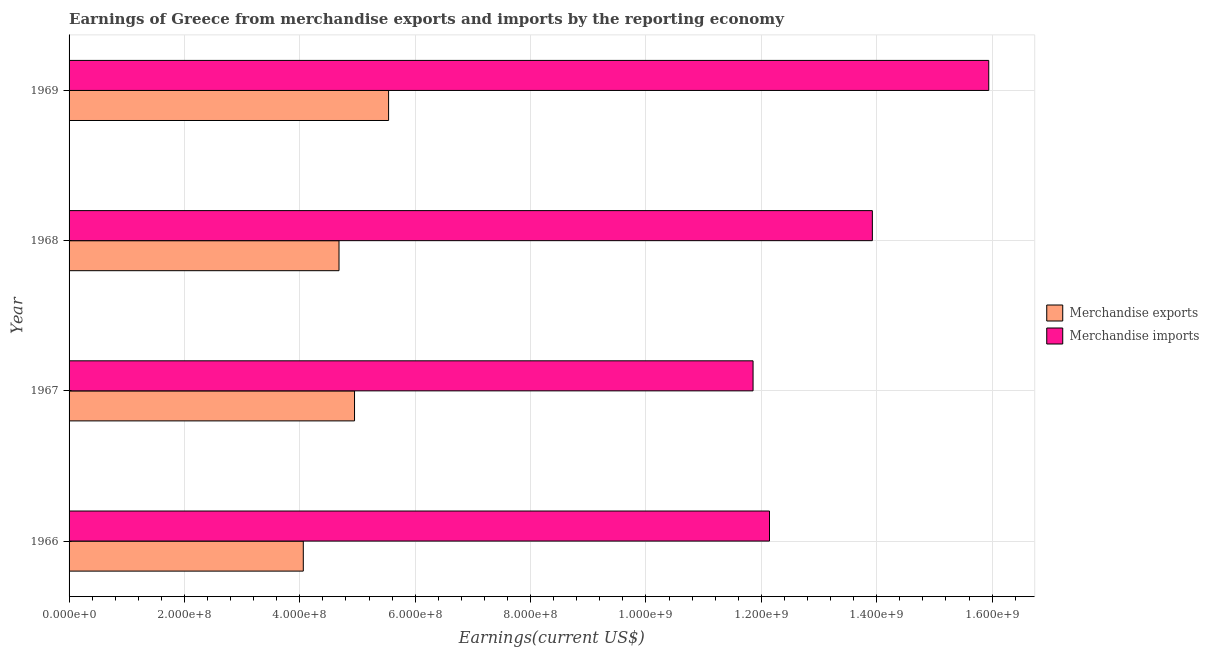Are the number of bars on each tick of the Y-axis equal?
Make the answer very short. Yes. What is the label of the 1st group of bars from the top?
Give a very brief answer. 1969. What is the earnings from merchandise exports in 1968?
Ensure brevity in your answer.  4.68e+08. Across all years, what is the maximum earnings from merchandise exports?
Make the answer very short. 5.54e+08. Across all years, what is the minimum earnings from merchandise exports?
Keep it short and to the point. 4.06e+08. In which year was the earnings from merchandise imports maximum?
Keep it short and to the point. 1969. In which year was the earnings from merchandise exports minimum?
Provide a short and direct response. 1966. What is the total earnings from merchandise exports in the graph?
Ensure brevity in your answer.  1.92e+09. What is the difference between the earnings from merchandise exports in 1967 and that in 1968?
Keep it short and to the point. 2.69e+07. What is the difference between the earnings from merchandise imports in 1966 and the earnings from merchandise exports in 1967?
Provide a short and direct response. 7.19e+08. What is the average earnings from merchandise exports per year?
Provide a succinct answer. 4.81e+08. In the year 1968, what is the difference between the earnings from merchandise exports and earnings from merchandise imports?
Give a very brief answer. -9.24e+08. What is the ratio of the earnings from merchandise exports in 1966 to that in 1967?
Give a very brief answer. 0.82. What is the difference between the highest and the second highest earnings from merchandise imports?
Your answer should be compact. 2.02e+08. What is the difference between the highest and the lowest earnings from merchandise imports?
Provide a short and direct response. 4.09e+08. How many years are there in the graph?
Ensure brevity in your answer.  4. What is the difference between two consecutive major ticks on the X-axis?
Provide a succinct answer. 2.00e+08. Are the values on the major ticks of X-axis written in scientific E-notation?
Provide a short and direct response. Yes. Does the graph contain any zero values?
Offer a terse response. No. How many legend labels are there?
Make the answer very short. 2. What is the title of the graph?
Ensure brevity in your answer.  Earnings of Greece from merchandise exports and imports by the reporting economy. Does "Researchers" appear as one of the legend labels in the graph?
Ensure brevity in your answer.  No. What is the label or title of the X-axis?
Offer a terse response. Earnings(current US$). What is the Earnings(current US$) of Merchandise exports in 1966?
Provide a succinct answer. 4.06e+08. What is the Earnings(current US$) in Merchandise imports in 1966?
Offer a very short reply. 1.21e+09. What is the Earnings(current US$) of Merchandise exports in 1967?
Your response must be concise. 4.95e+08. What is the Earnings(current US$) in Merchandise imports in 1967?
Ensure brevity in your answer.  1.19e+09. What is the Earnings(current US$) in Merchandise exports in 1968?
Ensure brevity in your answer.  4.68e+08. What is the Earnings(current US$) in Merchandise imports in 1968?
Make the answer very short. 1.39e+09. What is the Earnings(current US$) of Merchandise exports in 1969?
Offer a terse response. 5.54e+08. What is the Earnings(current US$) of Merchandise imports in 1969?
Your answer should be very brief. 1.59e+09. Across all years, what is the maximum Earnings(current US$) in Merchandise exports?
Provide a succinct answer. 5.54e+08. Across all years, what is the maximum Earnings(current US$) in Merchandise imports?
Your answer should be compact. 1.59e+09. Across all years, what is the minimum Earnings(current US$) in Merchandise exports?
Ensure brevity in your answer.  4.06e+08. Across all years, what is the minimum Earnings(current US$) of Merchandise imports?
Ensure brevity in your answer.  1.19e+09. What is the total Earnings(current US$) in Merchandise exports in the graph?
Keep it short and to the point. 1.92e+09. What is the total Earnings(current US$) of Merchandise imports in the graph?
Ensure brevity in your answer.  5.39e+09. What is the difference between the Earnings(current US$) in Merchandise exports in 1966 and that in 1967?
Keep it short and to the point. -8.88e+07. What is the difference between the Earnings(current US$) of Merchandise imports in 1966 and that in 1967?
Your answer should be compact. 2.85e+07. What is the difference between the Earnings(current US$) in Merchandise exports in 1966 and that in 1968?
Provide a short and direct response. -6.19e+07. What is the difference between the Earnings(current US$) of Merchandise imports in 1966 and that in 1968?
Make the answer very short. -1.78e+08. What is the difference between the Earnings(current US$) in Merchandise exports in 1966 and that in 1969?
Your response must be concise. -1.48e+08. What is the difference between the Earnings(current US$) in Merchandise imports in 1966 and that in 1969?
Provide a short and direct response. -3.80e+08. What is the difference between the Earnings(current US$) of Merchandise exports in 1967 and that in 1968?
Give a very brief answer. 2.69e+07. What is the difference between the Earnings(current US$) in Merchandise imports in 1967 and that in 1968?
Your answer should be compact. -2.07e+08. What is the difference between the Earnings(current US$) in Merchandise exports in 1967 and that in 1969?
Make the answer very short. -5.90e+07. What is the difference between the Earnings(current US$) in Merchandise imports in 1967 and that in 1969?
Keep it short and to the point. -4.09e+08. What is the difference between the Earnings(current US$) of Merchandise exports in 1968 and that in 1969?
Your answer should be compact. -8.60e+07. What is the difference between the Earnings(current US$) in Merchandise imports in 1968 and that in 1969?
Ensure brevity in your answer.  -2.02e+08. What is the difference between the Earnings(current US$) in Merchandise exports in 1966 and the Earnings(current US$) in Merchandise imports in 1967?
Offer a terse response. -7.80e+08. What is the difference between the Earnings(current US$) in Merchandise exports in 1966 and the Earnings(current US$) in Merchandise imports in 1968?
Ensure brevity in your answer.  -9.86e+08. What is the difference between the Earnings(current US$) in Merchandise exports in 1966 and the Earnings(current US$) in Merchandise imports in 1969?
Make the answer very short. -1.19e+09. What is the difference between the Earnings(current US$) in Merchandise exports in 1967 and the Earnings(current US$) in Merchandise imports in 1968?
Offer a terse response. -8.98e+08. What is the difference between the Earnings(current US$) in Merchandise exports in 1967 and the Earnings(current US$) in Merchandise imports in 1969?
Keep it short and to the point. -1.10e+09. What is the difference between the Earnings(current US$) of Merchandise exports in 1968 and the Earnings(current US$) of Merchandise imports in 1969?
Offer a very short reply. -1.13e+09. What is the average Earnings(current US$) in Merchandise exports per year?
Provide a short and direct response. 4.81e+08. What is the average Earnings(current US$) in Merchandise imports per year?
Give a very brief answer. 1.35e+09. In the year 1966, what is the difference between the Earnings(current US$) in Merchandise exports and Earnings(current US$) in Merchandise imports?
Your answer should be very brief. -8.08e+08. In the year 1967, what is the difference between the Earnings(current US$) of Merchandise exports and Earnings(current US$) of Merchandise imports?
Make the answer very short. -6.91e+08. In the year 1968, what is the difference between the Earnings(current US$) in Merchandise exports and Earnings(current US$) in Merchandise imports?
Give a very brief answer. -9.24e+08. In the year 1969, what is the difference between the Earnings(current US$) in Merchandise exports and Earnings(current US$) in Merchandise imports?
Ensure brevity in your answer.  -1.04e+09. What is the ratio of the Earnings(current US$) of Merchandise exports in 1966 to that in 1967?
Give a very brief answer. 0.82. What is the ratio of the Earnings(current US$) in Merchandise imports in 1966 to that in 1967?
Your answer should be very brief. 1.02. What is the ratio of the Earnings(current US$) in Merchandise exports in 1966 to that in 1968?
Ensure brevity in your answer.  0.87. What is the ratio of the Earnings(current US$) of Merchandise imports in 1966 to that in 1968?
Ensure brevity in your answer.  0.87. What is the ratio of the Earnings(current US$) of Merchandise exports in 1966 to that in 1969?
Keep it short and to the point. 0.73. What is the ratio of the Earnings(current US$) in Merchandise imports in 1966 to that in 1969?
Offer a terse response. 0.76. What is the ratio of the Earnings(current US$) in Merchandise exports in 1967 to that in 1968?
Your answer should be compact. 1.06. What is the ratio of the Earnings(current US$) of Merchandise imports in 1967 to that in 1968?
Provide a short and direct response. 0.85. What is the ratio of the Earnings(current US$) of Merchandise exports in 1967 to that in 1969?
Provide a succinct answer. 0.89. What is the ratio of the Earnings(current US$) of Merchandise imports in 1967 to that in 1969?
Keep it short and to the point. 0.74. What is the ratio of the Earnings(current US$) in Merchandise exports in 1968 to that in 1969?
Offer a very short reply. 0.84. What is the ratio of the Earnings(current US$) in Merchandise imports in 1968 to that in 1969?
Keep it short and to the point. 0.87. What is the difference between the highest and the second highest Earnings(current US$) in Merchandise exports?
Offer a very short reply. 5.90e+07. What is the difference between the highest and the second highest Earnings(current US$) of Merchandise imports?
Ensure brevity in your answer.  2.02e+08. What is the difference between the highest and the lowest Earnings(current US$) of Merchandise exports?
Make the answer very short. 1.48e+08. What is the difference between the highest and the lowest Earnings(current US$) in Merchandise imports?
Provide a succinct answer. 4.09e+08. 